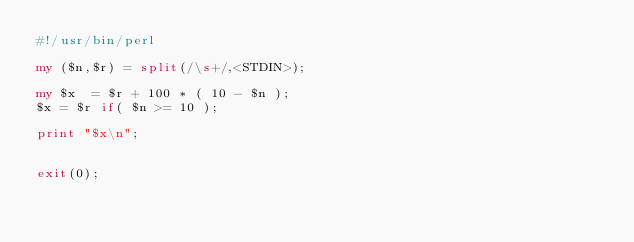<code> <loc_0><loc_0><loc_500><loc_500><_Perl_>#!/usr/bin/perl

my ($n,$r) = split(/\s+/,<STDIN>);

my $x  = $r + 100 * ( 10 - $n );
$x = $r if( $n >= 10 );

print "$x\n";


exit(0);
</code> 